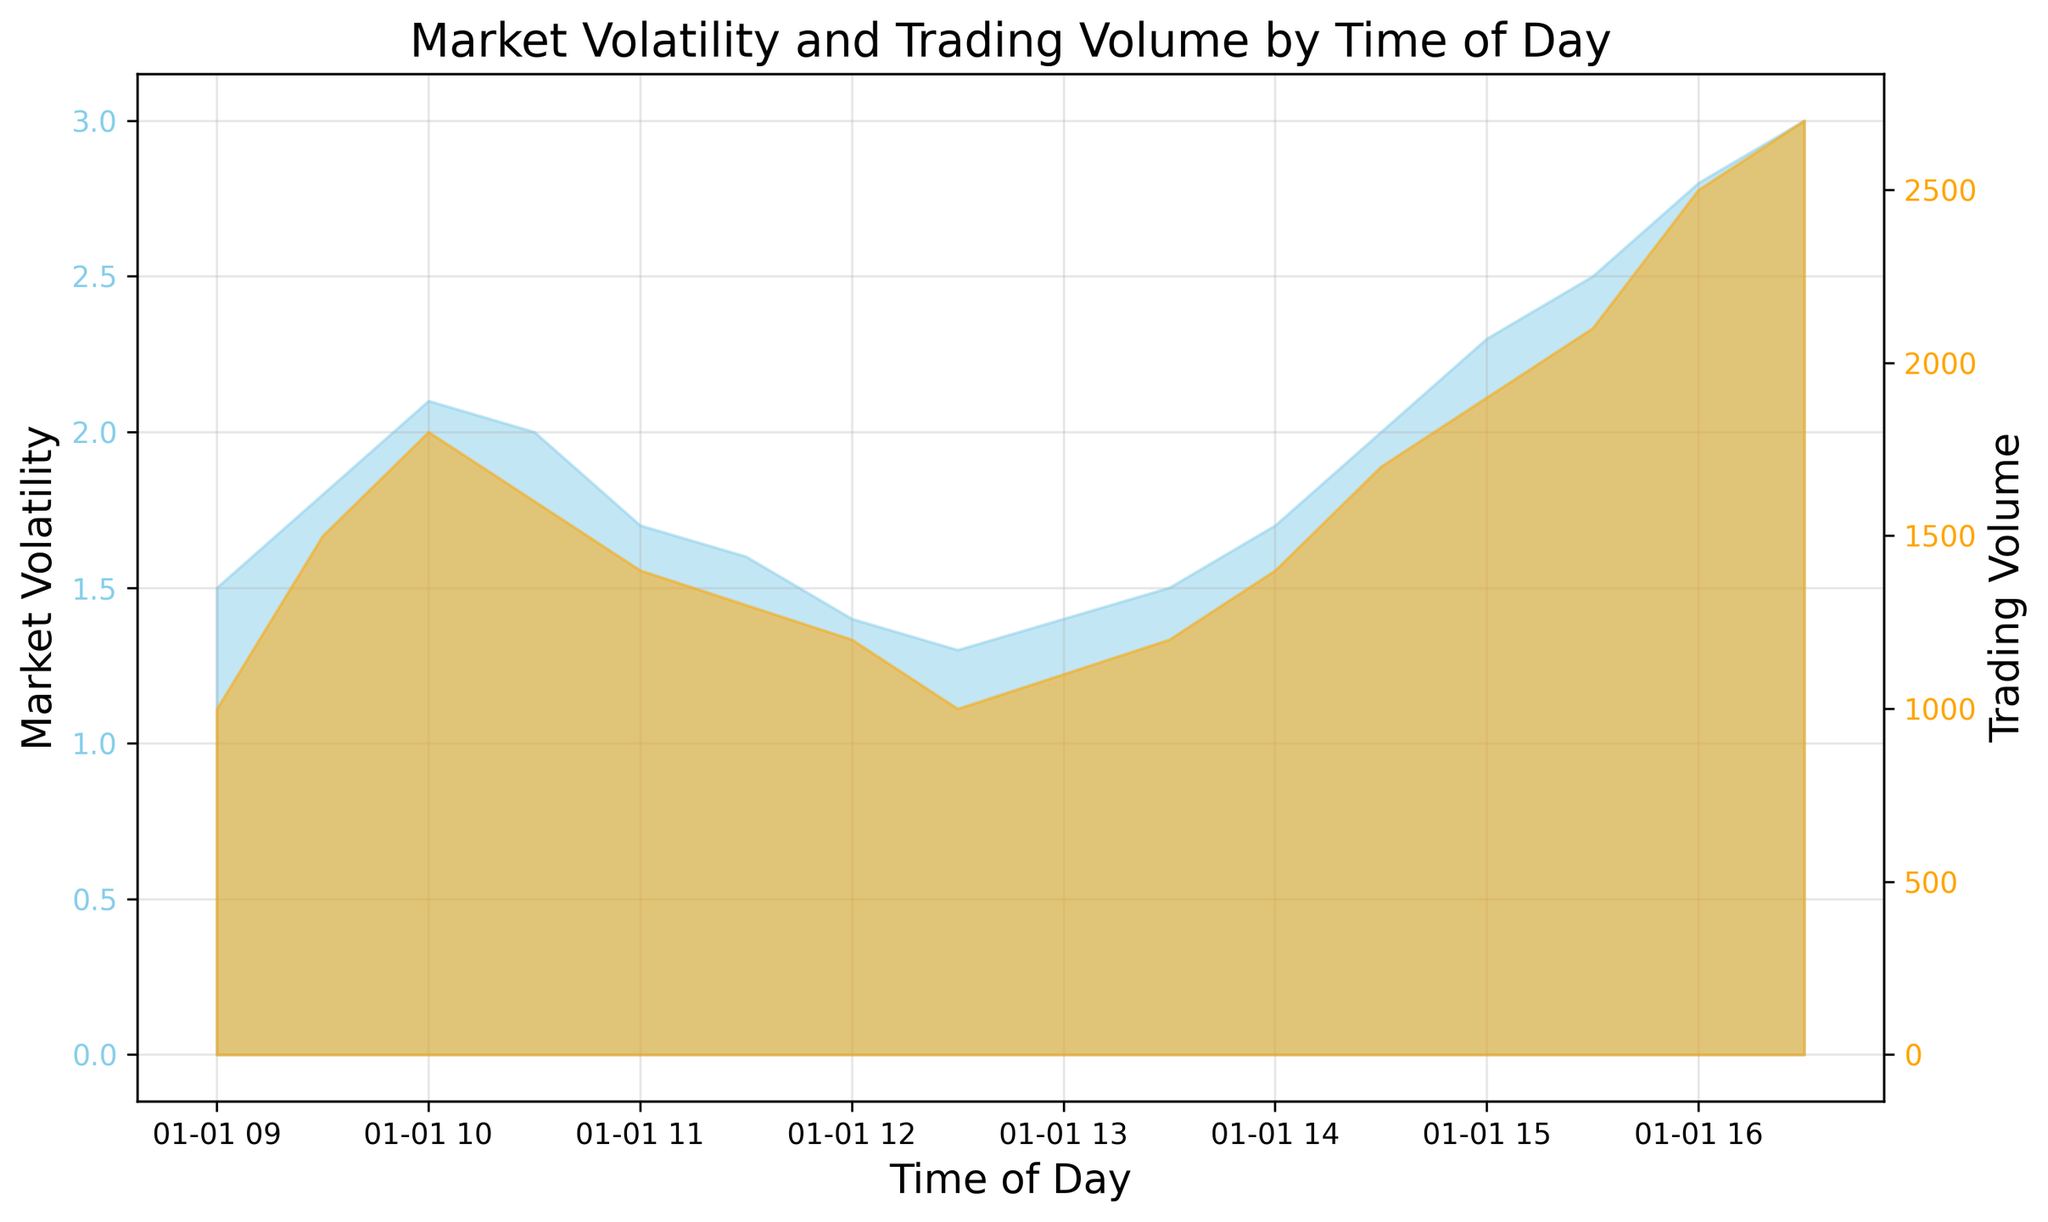What is the highest value of market volatility and at what time does it occur? The highest value of market volatility can be found by looking at the peak of the blue area in the chart. The maximum value observed is 3.0, and it occurs around 16:30.
Answer: 3.0 at 16:30 Which period between 09:00 and 16:30 has the highest trading volume? By examining the orange area, the highest trading volume is at the peak of the chart, which is 2700. This occurs at the time 16:30.
Answer: 16:30 How do market volatility and trading volume values correlate at 12:00? At 12:00, the market volatility and trading volume values can be observed in the chart. Market volatility is 1.4, and trading volume is 1200. Hence, both values can be noted directly from the respective points at 12:00 on their scales.
Answer: 1.4 and 1200 What is the difference between the trading volumes at 09:30 and 15:30? The trading volumes at 09:30 and 15:30 can be found in the chart. At 09:30, the volume is 1500, and at 15:30, it is 2100. The difference between them is 2100 - 1500 = 600.
Answer: 600 Between 11:00 and 13:00, does market volatility increase or decrease, and by how much? First, observe market volatility at 11:00, which is 1.7, and at 13:00, which is 1.4. The difference between these values indicates that market volatility decreases by 1.7 - 1.4 = 0.3.
Answer: Decreases by 0.3 During what period does market volatility experience its largest single increase? The largest single increase can be found by examining successive points where the blue area significantly rises. The largest increase is from 15:30 to 16:30, where market volatility rises from 2.5 to 3.0, an increase of 3.0 - 2.5 = 0.5.
Answer: 15:30 to 16:30, increase of 0.5 At what time does trading volume first exceed 2000, and by how much does it exceed? The trading volume first exceeds 2000 at 15:30, where it reaches 2100. It exceeds 2000 by 2100 - 2000 = 100.
Answer: 15:30, exceeds by 100 What is the average market volatility between 13:00 and 15:00? Market volatility at 13:00, 13:30, 14:00, 14:30, and 15:00 are 1.4, 1.5, 1.7, 2.0, and 2.3 respectively. The average is (1.4 + 1.5 + 1.7 + 2.0 + 2.3) / 5 = 1.78.
Answer: 1.78 